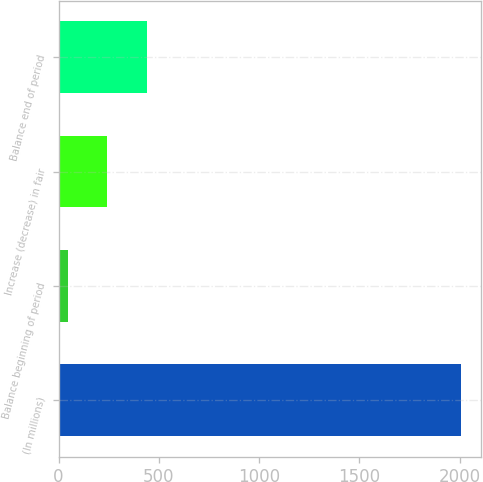Convert chart to OTSL. <chart><loc_0><loc_0><loc_500><loc_500><bar_chart><fcel>(In millions)<fcel>Balance beginning of period<fcel>Increase (decrease) in fair<fcel>Balance end of period<nl><fcel>2008<fcel>47<fcel>243.1<fcel>439.2<nl></chart> 